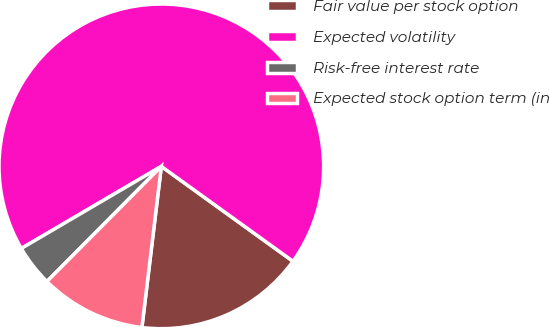Convert chart. <chart><loc_0><loc_0><loc_500><loc_500><pie_chart><fcel>Fair value per stock option<fcel>Expected volatility<fcel>Risk-free interest rate<fcel>Expected stock option term (in<nl><fcel>16.97%<fcel>68.38%<fcel>4.11%<fcel>10.54%<nl></chart> 